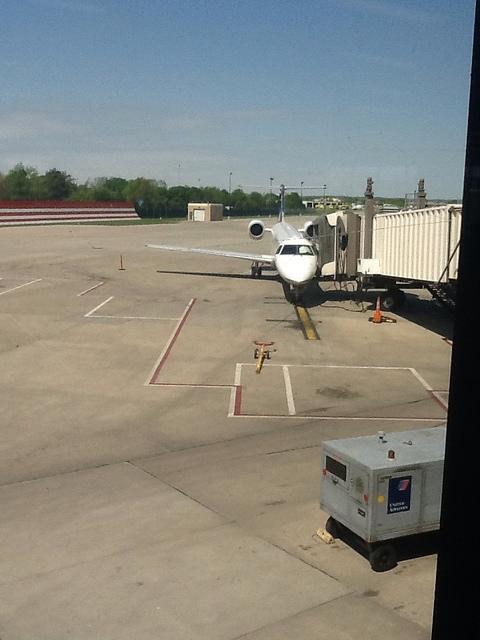What is the large metal thing on the right?
Write a very short answer. Airplane connector. Is the ground damp?
Answer briefly. No. Where is the plane sitting?
Give a very brief answer. Runway. How many vehicles are shown?
Give a very brief answer. 1. Is the airport busy?
Answer briefly. No. What color is the plane?
Concise answer only. White. 